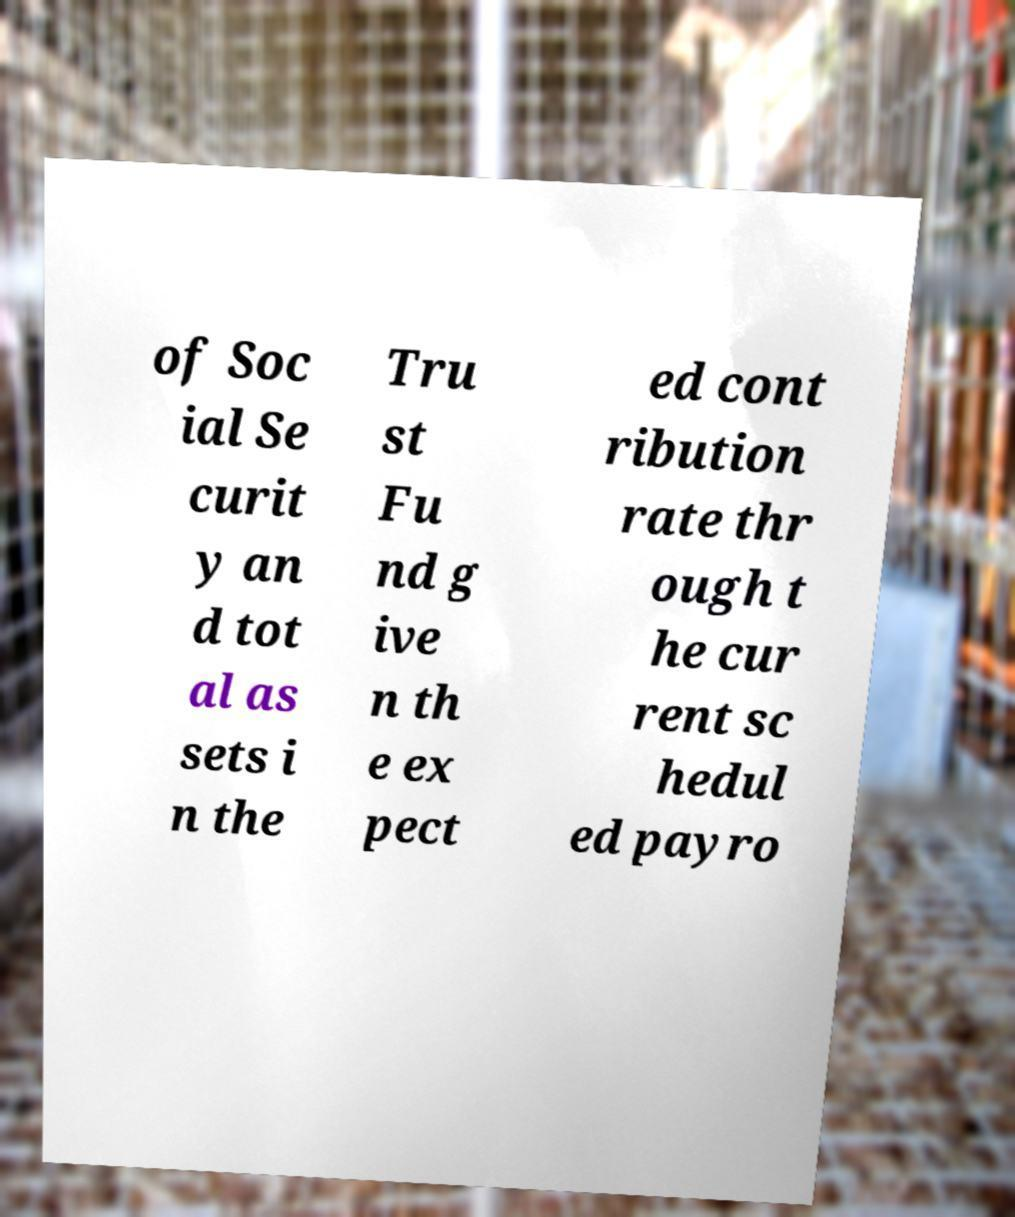I need the written content from this picture converted into text. Can you do that? of Soc ial Se curit y an d tot al as sets i n the Tru st Fu nd g ive n th e ex pect ed cont ribution rate thr ough t he cur rent sc hedul ed payro 